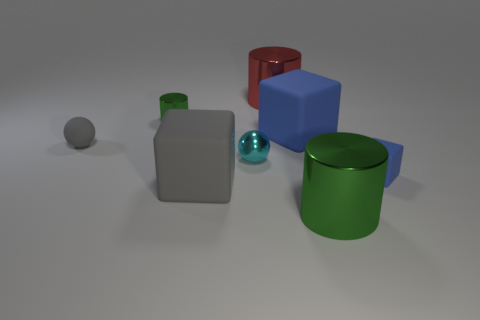Add 2 big metal things. How many objects exist? 10 Subtract all cylinders. How many objects are left? 5 Subtract 0 yellow cubes. How many objects are left? 8 Subtract all big cubes. Subtract all gray cubes. How many objects are left? 5 Add 1 small cyan objects. How many small cyan objects are left? 2 Add 3 large cyan rubber blocks. How many large cyan rubber blocks exist? 3 